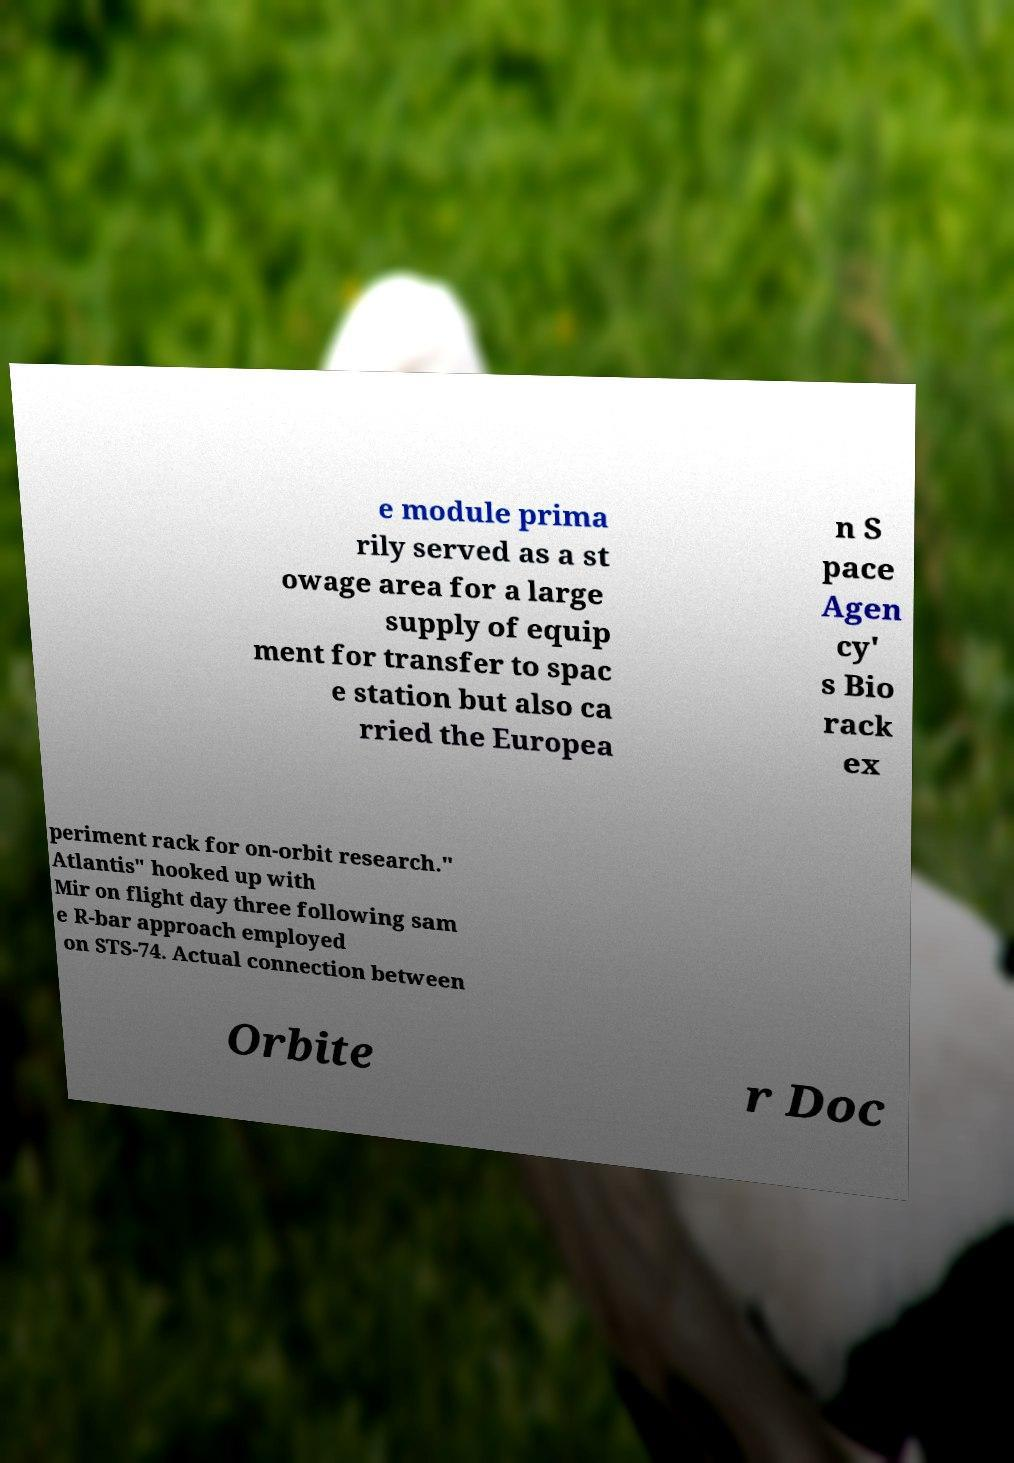For documentation purposes, I need the text within this image transcribed. Could you provide that? e module prima rily served as a st owage area for a large supply of equip ment for transfer to spac e station but also ca rried the Europea n S pace Agen cy' s Bio rack ex periment rack for on-orbit research." Atlantis" hooked up with Mir on flight day three following sam e R-bar approach employed on STS-74. Actual connection between Orbite r Doc 